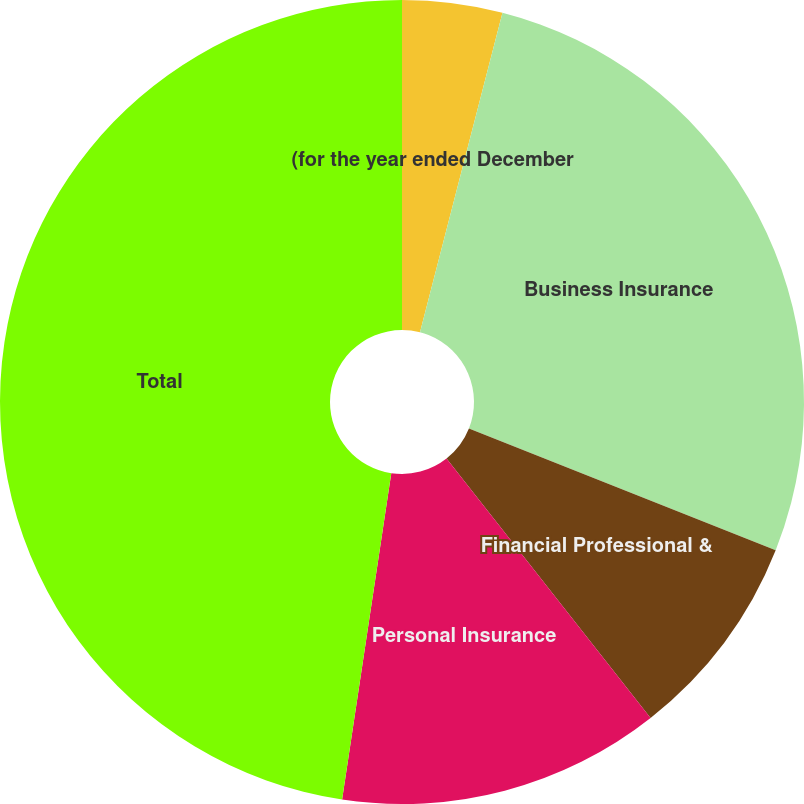Convert chart to OTSL. <chart><loc_0><loc_0><loc_500><loc_500><pie_chart><fcel>(for the year ended December<fcel>Business Insurance<fcel>Financial Professional &<fcel>Personal Insurance<fcel>Total<nl><fcel>4.02%<fcel>26.99%<fcel>8.38%<fcel>12.99%<fcel>47.62%<nl></chart> 